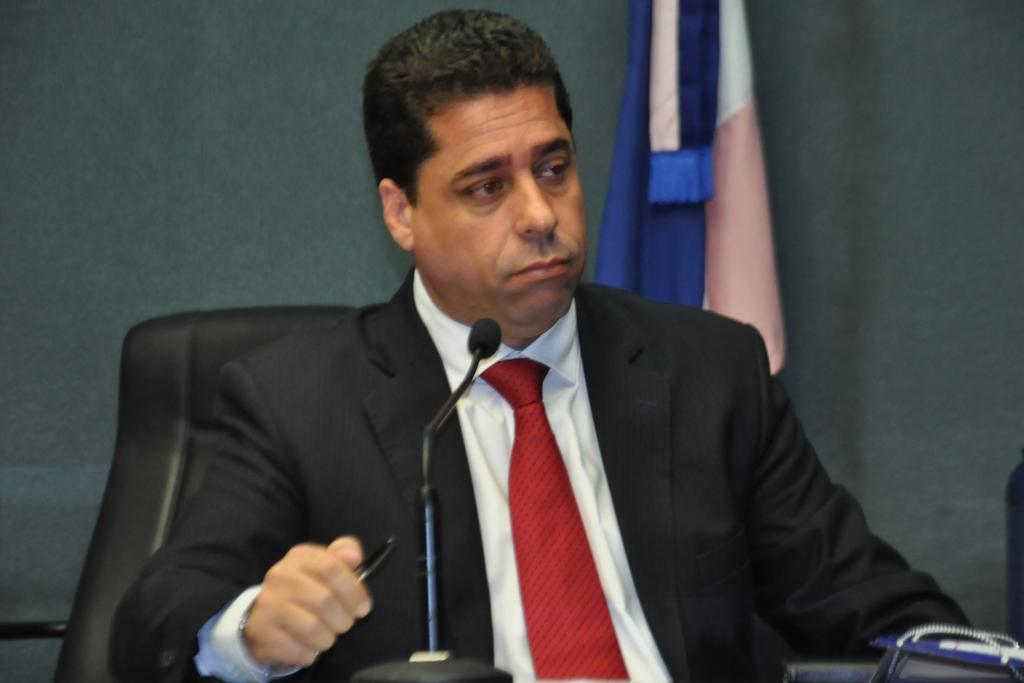What is the main subject of the image? There is a person in the image. What is the person wearing? The person is wearing clothes. What is the person doing in the image? The person is sitting on a chair and holding a pen. What object is the person in front of? The person is in front of a mic. What can be seen on the wall behind the person? There is a flag in front of the wall. What type of juice is the person drinking in the image? There is no juice present in the image; the person is holding a pen and sitting in front of a mic. How far away is the person from the wall in the image? The distance between the person and the wall cannot be determined from the image alone. 